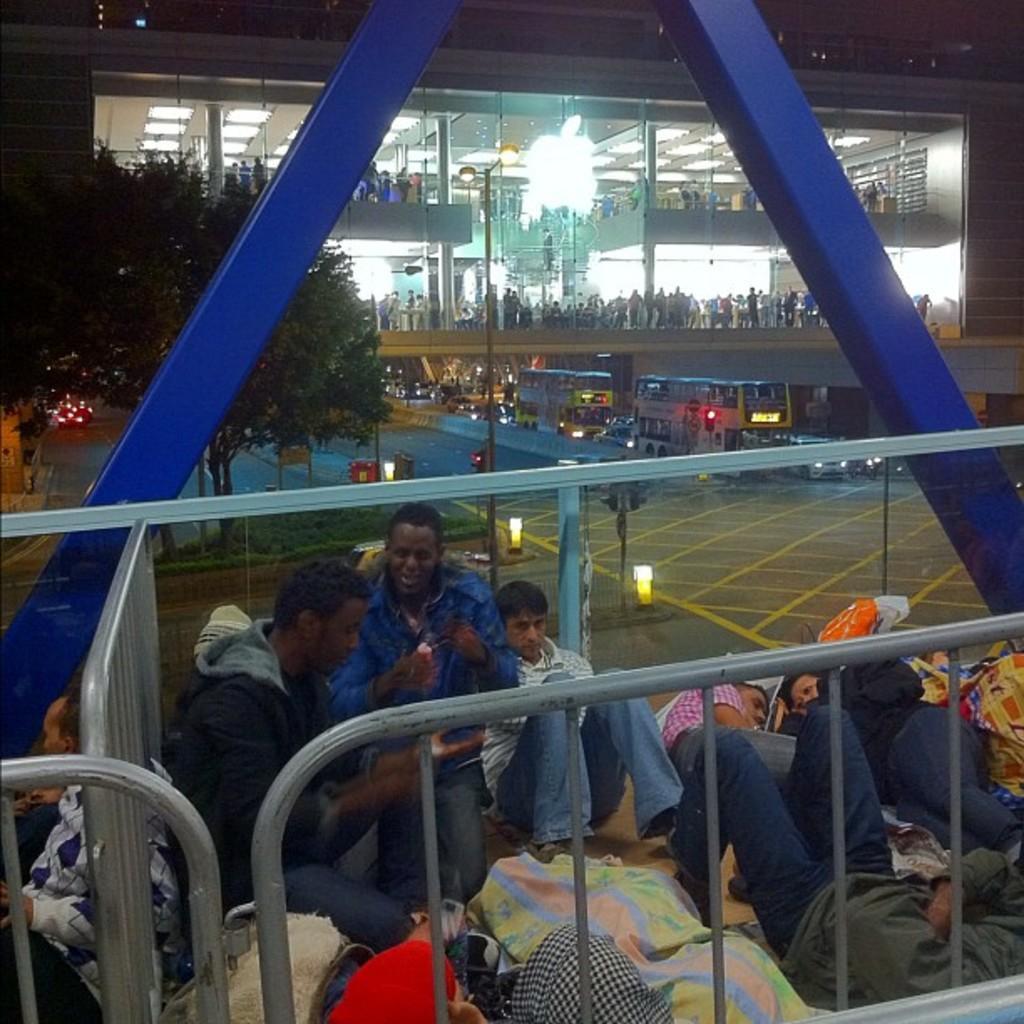Please provide a concise description of this image. In this picture there are some people sitting and laying on the floor. I can observe a railing. In the background there is a building and I can observe some people in the building. There are some buses on the road. On the left side there are some trees. 